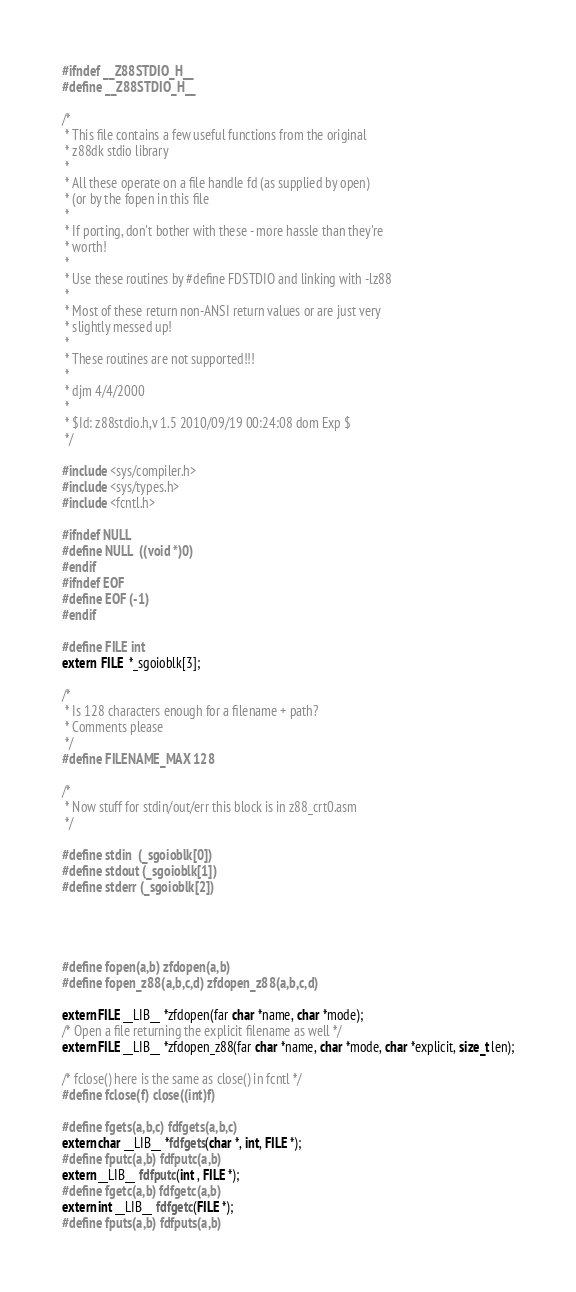Convert code to text. <code><loc_0><loc_0><loc_500><loc_500><_C_>#ifndef __Z88STDIO_H__
#define __Z88STDIO_H__

/*
 * This file contains a few useful functions from the original
 * z88dk stdio library
 *
 * All these operate on a file handle fd (as supplied by open)
 * (or by the fopen in this file
 *
 * If porting, don't bother with these - more hassle than they're
 * worth!
 *
 * Use these routines by #define FDSTDIO and linking with -lz88
 *
 * Most of these return non-ANSI return values or are just very
 * slightly messed up!
 *
 * These routines are not supported!!!
 *
 * djm 4/4/2000
 *
 * $Id: z88stdio.h,v 1.5 2010/09/19 00:24:08 dom Exp $
 */

#include <sys/compiler.h>
#include <sys/types.h>
#include <fcntl.h>

#ifndef NULL
#define NULL  ((void *)0)
#endif
#ifndef EOF
#define EOF (-1)
#endif

#define FILE int
extern  FILE  *_sgoioblk[3];

/*
 * Is 128 characters enough for a filename + path?
 * Comments please
 */
#define FILENAME_MAX 128

/*
 * Now stuff for stdin/out/err this block is in z88_crt0.asm
 */

#define stdin  (_sgoioblk[0])
#define stdout (_sgoioblk[1])
#define stderr (_sgoioblk[2])




#define fopen(a,b) zfdopen(a,b)
#define fopen_z88(a,b,c,d) zfdopen_z88(a,b,c,d)

extern FILE __LIB__ *zfdopen(far char *name, char *mode);
/* Open a file returning the explicit filename as well */
extern FILE __LIB__ *zfdopen_z88(far char *name, char *mode, char *explicit, size_t len);

/* fclose() here is the same as close() in fcntl */
#define fclose(f) close((int)f)

#define fgets(a,b,c) fdfgets(a,b,c)
extern char __LIB__ *fdfgets(char *, int, FILE *);
#define fputc(a,b) fdfputc(a,b)
extern __LIB__ fdfputc(int , FILE *);
#define fgetc(a,b) fdfgetc(a,b)
extern int __LIB__ fdfgetc(FILE *);
#define fputs(a,b) fdfputs(a,b)</code> 